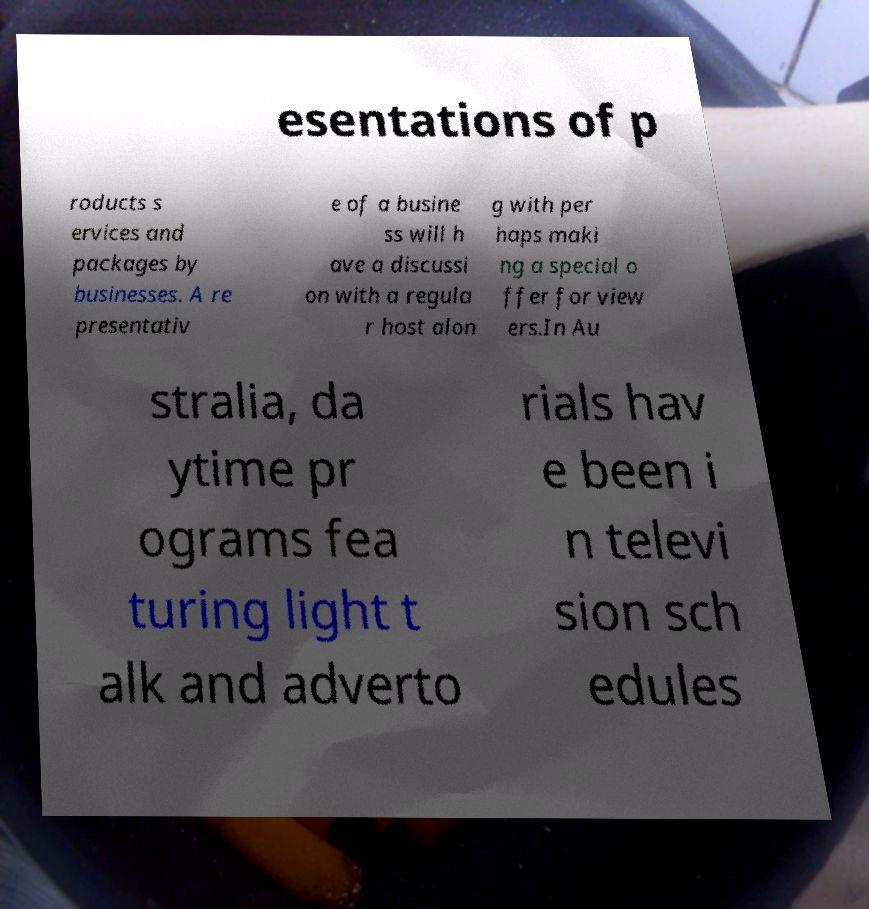Please identify and transcribe the text found in this image. esentations of p roducts s ervices and packages by businesses. A re presentativ e of a busine ss will h ave a discussi on with a regula r host alon g with per haps maki ng a special o ffer for view ers.In Au stralia, da ytime pr ograms fea turing light t alk and adverto rials hav e been i n televi sion sch edules 